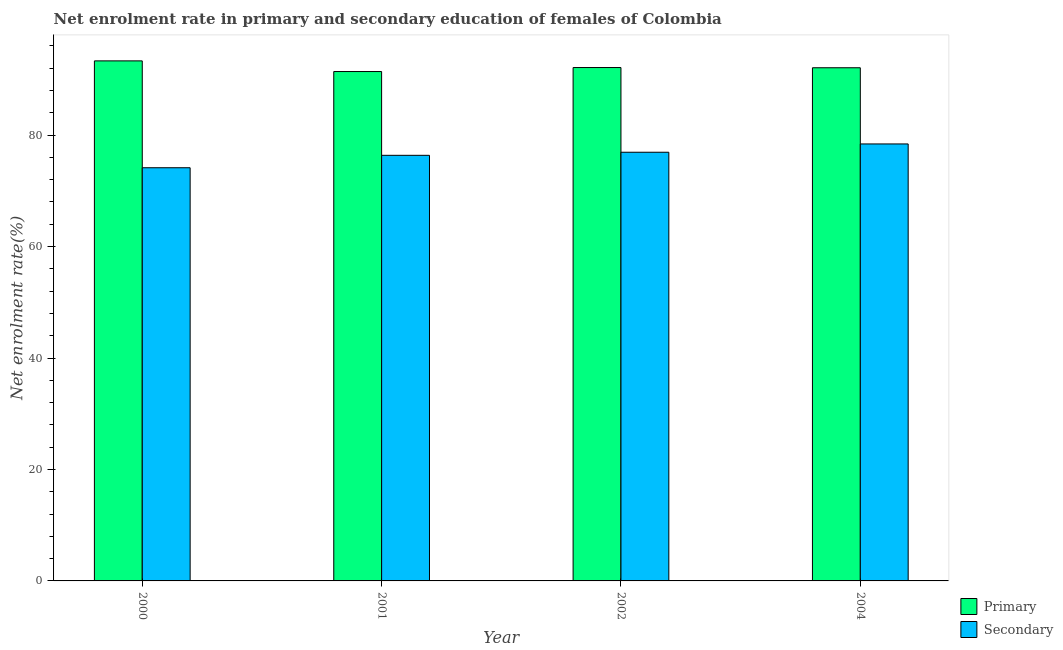How many different coloured bars are there?
Your answer should be compact. 2. Are the number of bars on each tick of the X-axis equal?
Give a very brief answer. Yes. How many bars are there on the 1st tick from the right?
Ensure brevity in your answer.  2. What is the label of the 3rd group of bars from the left?
Make the answer very short. 2002. What is the enrollment rate in primary education in 2001?
Your response must be concise. 91.4. Across all years, what is the maximum enrollment rate in secondary education?
Keep it short and to the point. 78.41. Across all years, what is the minimum enrollment rate in secondary education?
Give a very brief answer. 74.14. In which year was the enrollment rate in secondary education maximum?
Your response must be concise. 2004. In which year was the enrollment rate in secondary education minimum?
Give a very brief answer. 2000. What is the total enrollment rate in primary education in the graph?
Make the answer very short. 368.92. What is the difference between the enrollment rate in primary education in 2001 and that in 2002?
Ensure brevity in your answer.  -0.72. What is the difference between the enrollment rate in primary education in 2001 and the enrollment rate in secondary education in 2004?
Offer a very short reply. -0.68. What is the average enrollment rate in primary education per year?
Offer a very short reply. 92.23. In how many years, is the enrollment rate in primary education greater than 36 %?
Provide a short and direct response. 4. What is the ratio of the enrollment rate in primary education in 2000 to that in 2004?
Your answer should be very brief. 1.01. What is the difference between the highest and the second highest enrollment rate in primary education?
Your answer should be very brief. 1.2. What is the difference between the highest and the lowest enrollment rate in secondary education?
Offer a terse response. 4.27. In how many years, is the enrollment rate in secondary education greater than the average enrollment rate in secondary education taken over all years?
Offer a terse response. 2. What does the 1st bar from the left in 2001 represents?
Ensure brevity in your answer.  Primary. What does the 1st bar from the right in 2000 represents?
Your answer should be compact. Secondary. How many bars are there?
Offer a very short reply. 8. What is the difference between two consecutive major ticks on the Y-axis?
Offer a terse response. 20. Where does the legend appear in the graph?
Ensure brevity in your answer.  Bottom right. How are the legend labels stacked?
Your response must be concise. Vertical. What is the title of the graph?
Ensure brevity in your answer.  Net enrolment rate in primary and secondary education of females of Colombia. Does "Canada" appear as one of the legend labels in the graph?
Offer a terse response. No. What is the label or title of the Y-axis?
Offer a terse response. Net enrolment rate(%). What is the Net enrolment rate(%) in Primary in 2000?
Keep it short and to the point. 93.32. What is the Net enrolment rate(%) of Secondary in 2000?
Provide a short and direct response. 74.14. What is the Net enrolment rate(%) of Primary in 2001?
Your answer should be compact. 91.4. What is the Net enrolment rate(%) of Secondary in 2001?
Your answer should be very brief. 76.37. What is the Net enrolment rate(%) of Primary in 2002?
Offer a terse response. 92.12. What is the Net enrolment rate(%) of Secondary in 2002?
Make the answer very short. 76.92. What is the Net enrolment rate(%) of Primary in 2004?
Offer a terse response. 92.08. What is the Net enrolment rate(%) in Secondary in 2004?
Make the answer very short. 78.41. Across all years, what is the maximum Net enrolment rate(%) in Primary?
Provide a short and direct response. 93.32. Across all years, what is the maximum Net enrolment rate(%) of Secondary?
Your answer should be compact. 78.41. Across all years, what is the minimum Net enrolment rate(%) in Primary?
Your answer should be compact. 91.4. Across all years, what is the minimum Net enrolment rate(%) of Secondary?
Offer a very short reply. 74.14. What is the total Net enrolment rate(%) in Primary in the graph?
Ensure brevity in your answer.  368.92. What is the total Net enrolment rate(%) of Secondary in the graph?
Offer a terse response. 305.84. What is the difference between the Net enrolment rate(%) in Primary in 2000 and that in 2001?
Give a very brief answer. 1.91. What is the difference between the Net enrolment rate(%) of Secondary in 2000 and that in 2001?
Your response must be concise. -2.23. What is the difference between the Net enrolment rate(%) in Primary in 2000 and that in 2002?
Offer a terse response. 1.2. What is the difference between the Net enrolment rate(%) in Secondary in 2000 and that in 2002?
Ensure brevity in your answer.  -2.78. What is the difference between the Net enrolment rate(%) of Primary in 2000 and that in 2004?
Your response must be concise. 1.23. What is the difference between the Net enrolment rate(%) of Secondary in 2000 and that in 2004?
Give a very brief answer. -4.27. What is the difference between the Net enrolment rate(%) in Primary in 2001 and that in 2002?
Provide a short and direct response. -0.72. What is the difference between the Net enrolment rate(%) of Secondary in 2001 and that in 2002?
Your response must be concise. -0.55. What is the difference between the Net enrolment rate(%) of Primary in 2001 and that in 2004?
Keep it short and to the point. -0.68. What is the difference between the Net enrolment rate(%) of Secondary in 2001 and that in 2004?
Provide a succinct answer. -2.04. What is the difference between the Net enrolment rate(%) in Primary in 2002 and that in 2004?
Provide a short and direct response. 0.04. What is the difference between the Net enrolment rate(%) in Secondary in 2002 and that in 2004?
Your answer should be compact. -1.49. What is the difference between the Net enrolment rate(%) in Primary in 2000 and the Net enrolment rate(%) in Secondary in 2001?
Your response must be concise. 16.95. What is the difference between the Net enrolment rate(%) of Primary in 2000 and the Net enrolment rate(%) of Secondary in 2002?
Offer a very short reply. 16.39. What is the difference between the Net enrolment rate(%) of Primary in 2000 and the Net enrolment rate(%) of Secondary in 2004?
Ensure brevity in your answer.  14.9. What is the difference between the Net enrolment rate(%) of Primary in 2001 and the Net enrolment rate(%) of Secondary in 2002?
Ensure brevity in your answer.  14.48. What is the difference between the Net enrolment rate(%) of Primary in 2001 and the Net enrolment rate(%) of Secondary in 2004?
Provide a succinct answer. 12.99. What is the difference between the Net enrolment rate(%) in Primary in 2002 and the Net enrolment rate(%) in Secondary in 2004?
Offer a terse response. 13.71. What is the average Net enrolment rate(%) in Primary per year?
Ensure brevity in your answer.  92.23. What is the average Net enrolment rate(%) in Secondary per year?
Give a very brief answer. 76.46. In the year 2000, what is the difference between the Net enrolment rate(%) in Primary and Net enrolment rate(%) in Secondary?
Offer a very short reply. 19.17. In the year 2001, what is the difference between the Net enrolment rate(%) in Primary and Net enrolment rate(%) in Secondary?
Provide a short and direct response. 15.03. In the year 2002, what is the difference between the Net enrolment rate(%) of Primary and Net enrolment rate(%) of Secondary?
Your answer should be very brief. 15.2. In the year 2004, what is the difference between the Net enrolment rate(%) of Primary and Net enrolment rate(%) of Secondary?
Offer a very short reply. 13.67. What is the ratio of the Net enrolment rate(%) in Primary in 2000 to that in 2001?
Your response must be concise. 1.02. What is the ratio of the Net enrolment rate(%) of Secondary in 2000 to that in 2001?
Your answer should be compact. 0.97. What is the ratio of the Net enrolment rate(%) of Secondary in 2000 to that in 2002?
Your answer should be very brief. 0.96. What is the ratio of the Net enrolment rate(%) of Primary in 2000 to that in 2004?
Your response must be concise. 1.01. What is the ratio of the Net enrolment rate(%) in Secondary in 2000 to that in 2004?
Offer a very short reply. 0.95. What is the ratio of the Net enrolment rate(%) of Primary in 2001 to that in 2004?
Ensure brevity in your answer.  0.99. What is the difference between the highest and the second highest Net enrolment rate(%) in Primary?
Your response must be concise. 1.2. What is the difference between the highest and the second highest Net enrolment rate(%) in Secondary?
Make the answer very short. 1.49. What is the difference between the highest and the lowest Net enrolment rate(%) of Primary?
Give a very brief answer. 1.91. What is the difference between the highest and the lowest Net enrolment rate(%) in Secondary?
Make the answer very short. 4.27. 